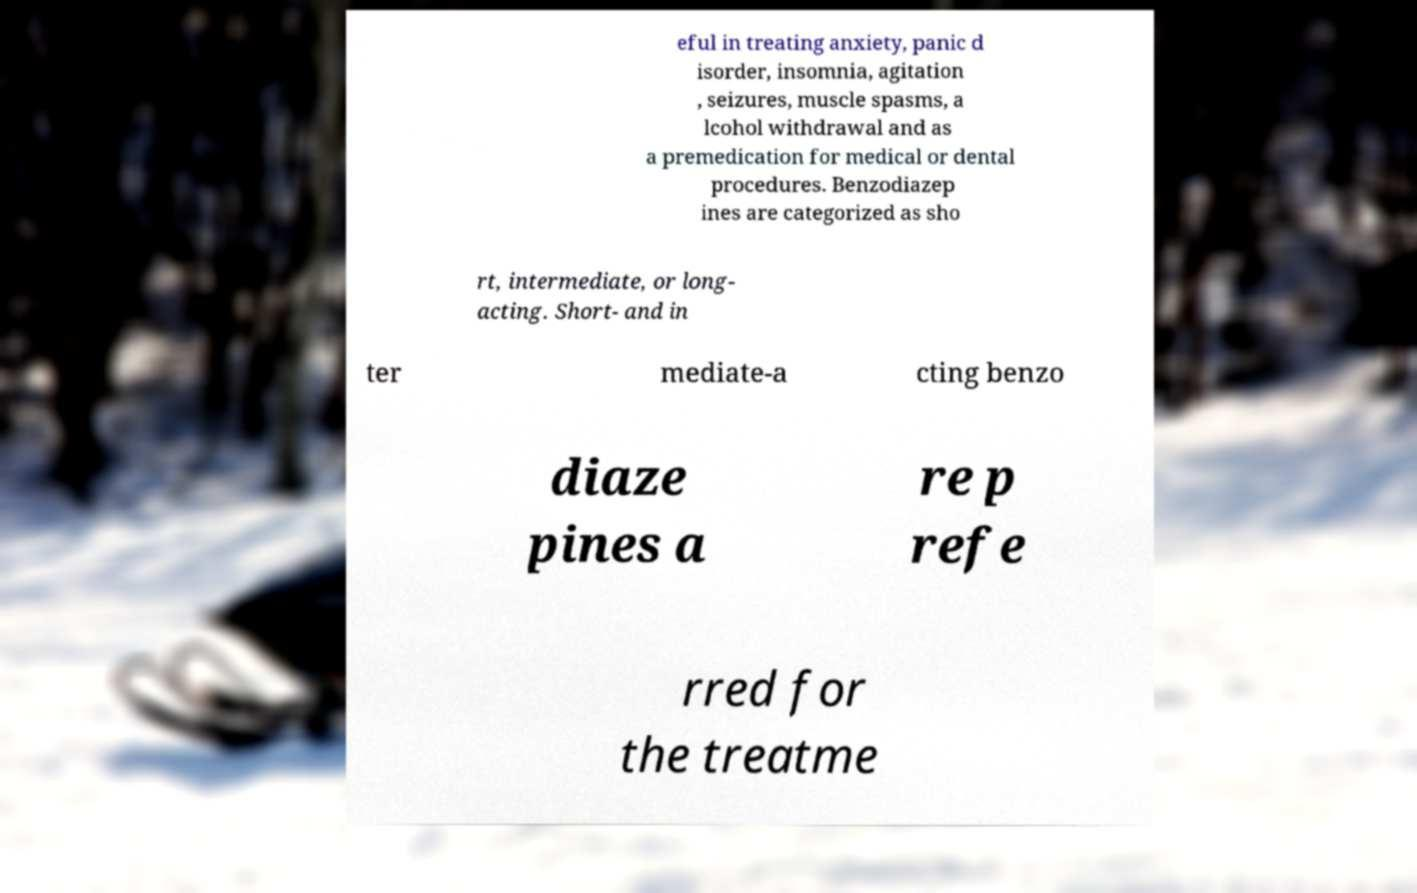What messages or text are displayed in this image? I need them in a readable, typed format. eful in treating anxiety, panic d isorder, insomnia, agitation , seizures, muscle spasms, a lcohol withdrawal and as a premedication for medical or dental procedures. Benzodiazep ines are categorized as sho rt, intermediate, or long- acting. Short- and in ter mediate-a cting benzo diaze pines a re p refe rred for the treatme 